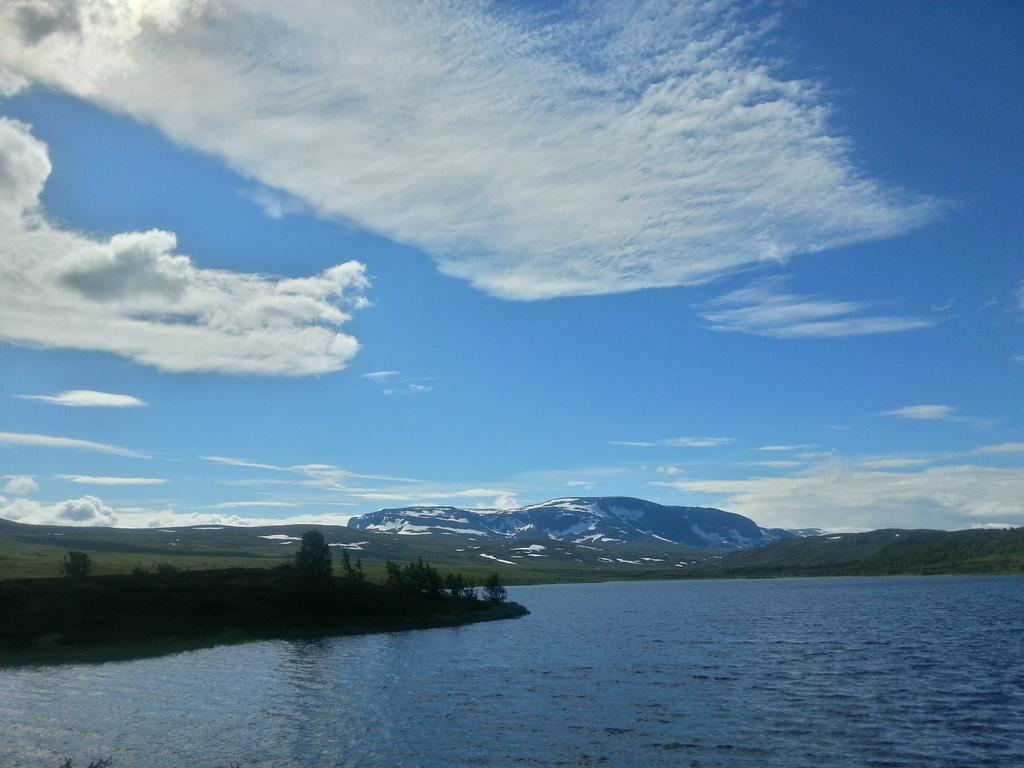What type of vegetation can be seen in the image? There are trees in the image. What natural element is visible in the image besides trees? There is water visible in the image. What type of ground cover is present in the image? There is grass in the image. What geographical feature can be seen in the distance? There are mountains in the image. What is visible in the background of the image? The sky is visible in the background of the image. What atmospheric feature can be seen in the sky? Clouds are present in the sky. How does the nail contribute to the overall aesthetic of the image? There is no nail present in the image, so it cannot contribute to the aesthetic. 